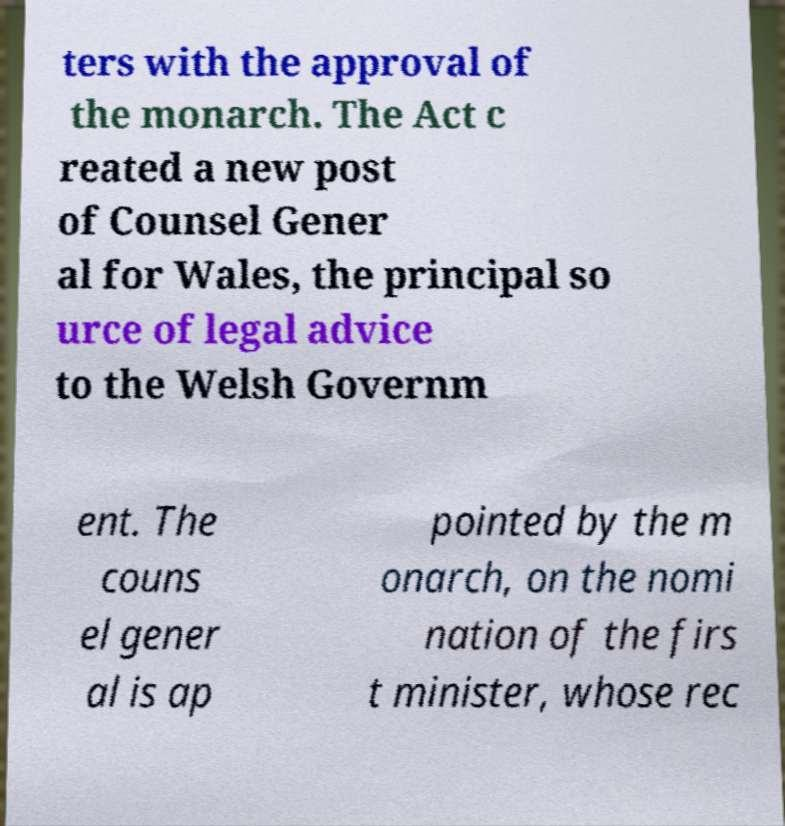Could you extract and type out the text from this image? ters with the approval of the monarch. The Act c reated a new post of Counsel Gener al for Wales, the principal so urce of legal advice to the Welsh Governm ent. The couns el gener al is ap pointed by the m onarch, on the nomi nation of the firs t minister, whose rec 